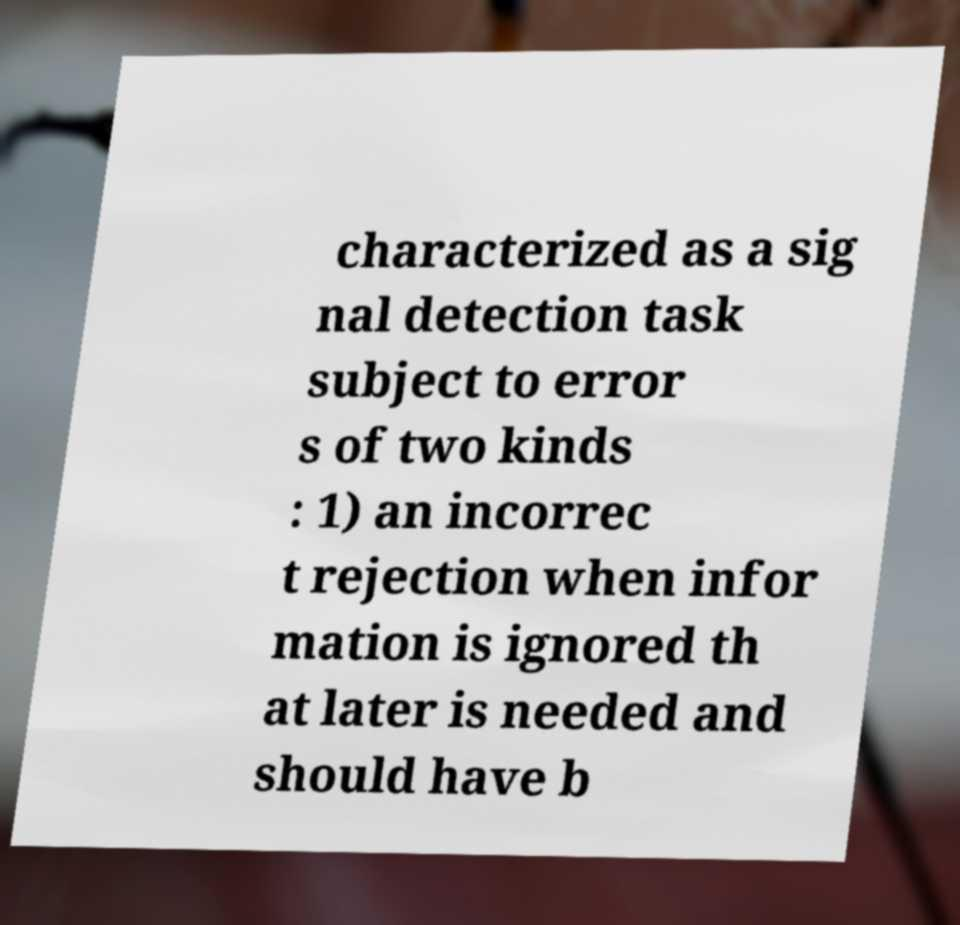What messages or text are displayed in this image? I need them in a readable, typed format. characterized as a sig nal detection task subject to error s of two kinds : 1) an incorrec t rejection when infor mation is ignored th at later is needed and should have b 